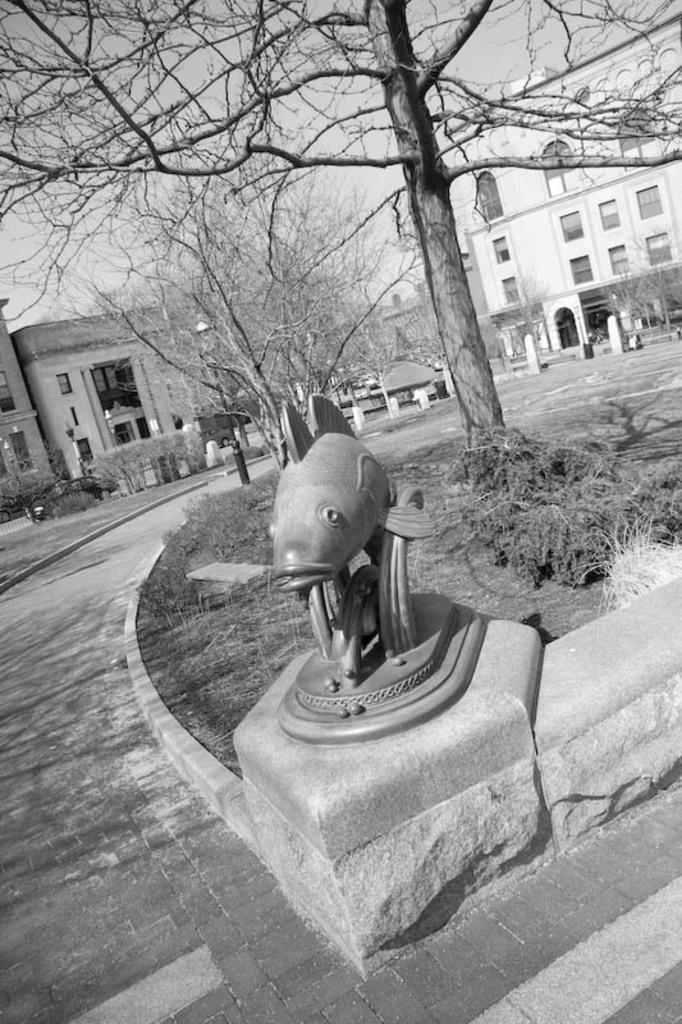Describe this image in one or two sentences. This image consists of a sculpture. At the bottom, there is a road. In the background, we can see the buildings. In the middle, there is a tree. In the middle, there is a tree. And at the bottom, we can grass on the ground. 